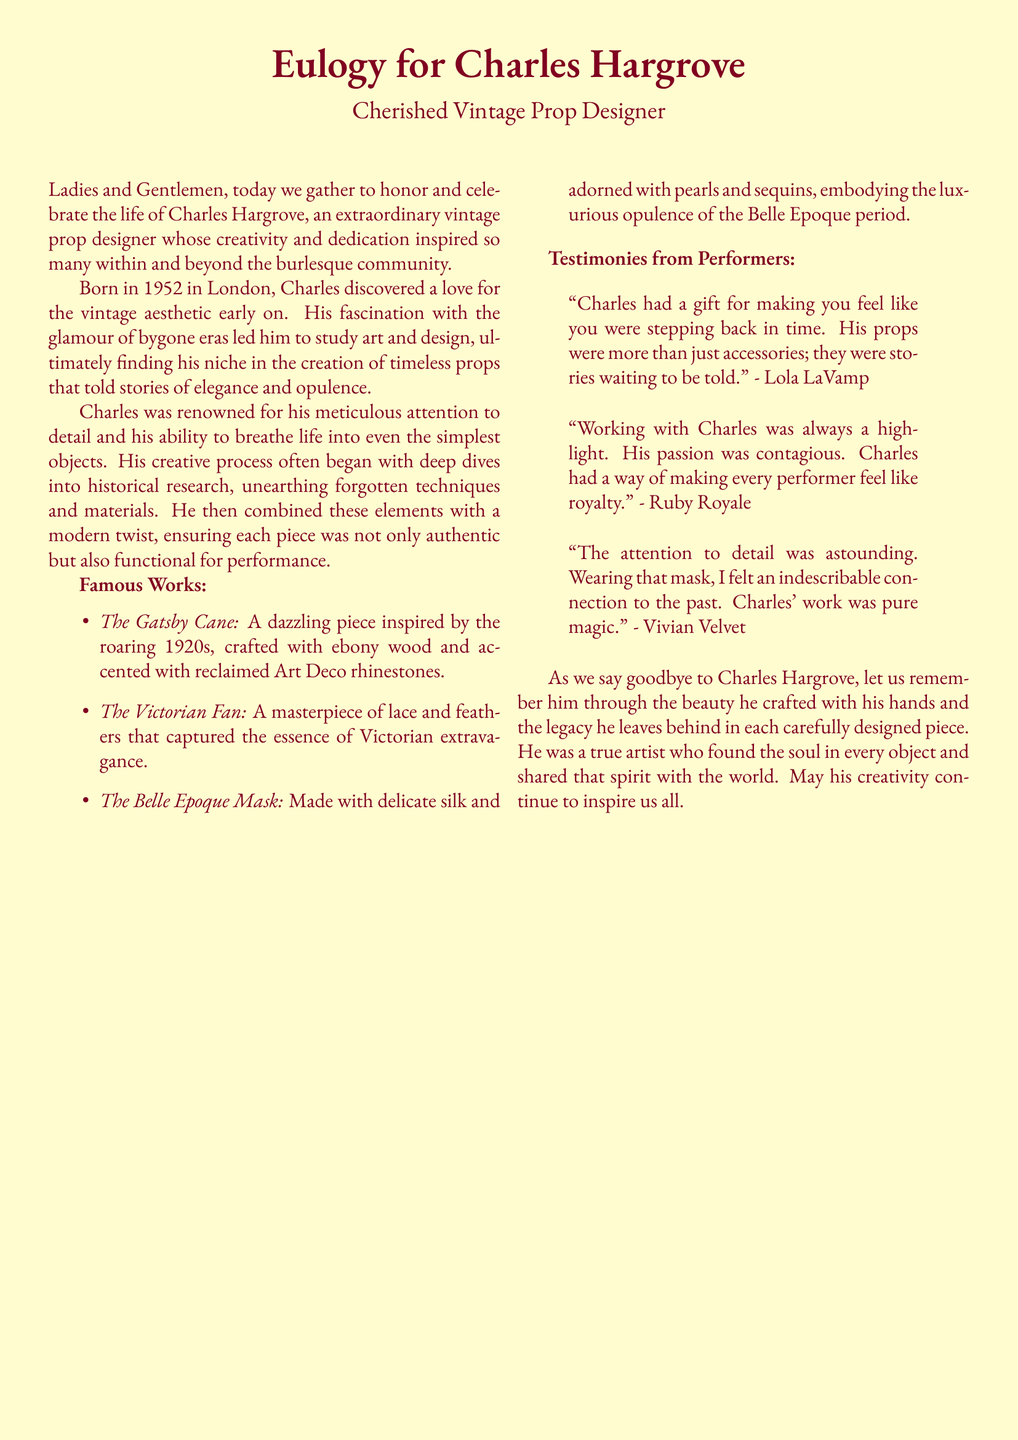What year was Charles Hargrove born? The document states that Charles Hargrove was born in 1952.
Answer: 1952 What was the name of Charles' job? The eulogy refers to Charles Hargrove as a vintage prop designer.
Answer: Vintage Prop Designer Name one of Charles' famous works. The document lists several works, such as "The Gatsby Cane."
Answer: The Gatsby Cane What materials were used in "The Belle Epoque Mask"? The eulogy describes "The Belle Epoque Mask" as made with delicate silk and adorned with pearls and sequins.
Answer: Delicate silk, pearls, sequins Who said, "His props were more than just accessories; they were stories waiting to be told"? The quote in the document is attributed to Lola LaVamp.
Answer: Lola LaVamp What did Charles' creative process often begin with? The eulogy explains that his creative process often began with deep dives into historical research.
Answer: Historical research Which decade inspired "The Gatsby Cane"? The document mentions that "The Gatsby Cane" was inspired by the roaring 1920s.
Answer: Roaring 1920s How did Charles make performers feel? The testimonies from performers indicate that he made them feel like royalty.
Answer: Like royalty 